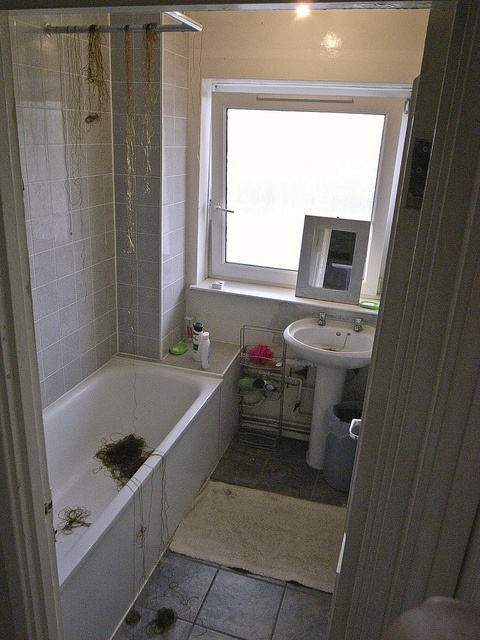Describe the objects in this image and their specific colors. I can see sink in black and gray tones and bottle in black and gray tones in this image. 